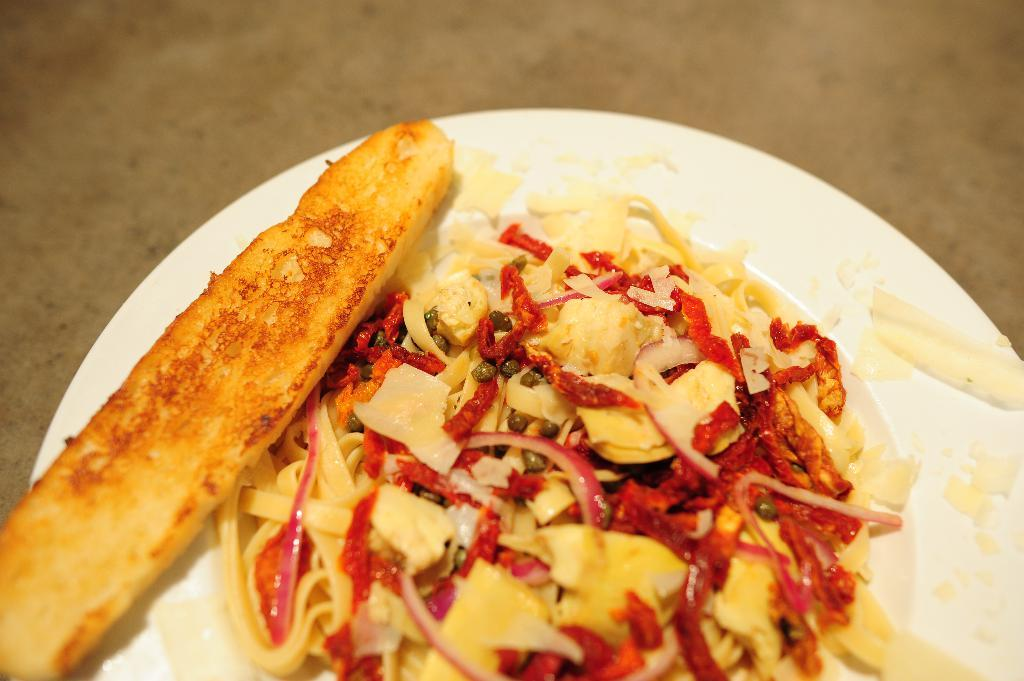What object is present in the image that typically holds food? There is a plate in the image that typically holds food. What is on the plate in the image? The plate contains food. Where is the plate located in the image? The plate is on a surface. What type of holiday decoration can be seen on the plate in the image? There is no holiday decoration present on the plate in the image. What room is the plate located in within the image? The provided facts do not specify the room where the plate is located. How many sheep are visible on the plate in the image? There are no sheep present on the plate in the image. 